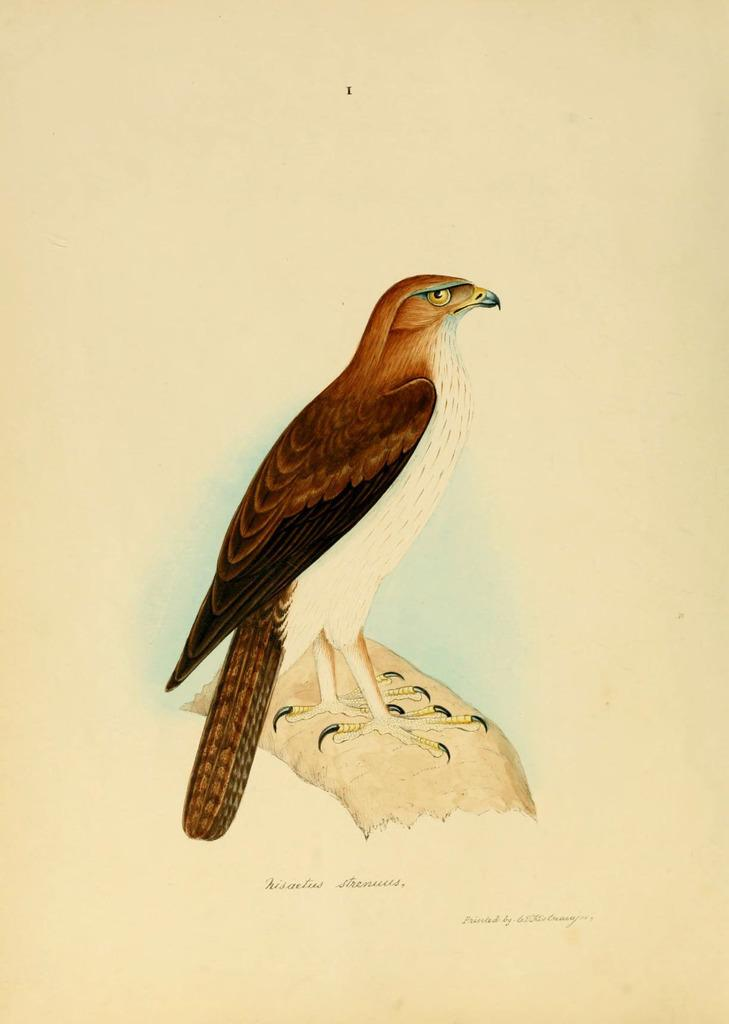What is the main subject of the image? There is a picture in the image. What is depicted in the picture? The picture contains a bird. Can you describe the bird's appearance? The bird has brown and white colors. What type of squirrel is wearing a stocking in the image? There is no squirrel or stocking present in the image; it features a picture of a bird with brown and white colors. How many bananas are visible in the image? There are no bananas present in the image. 